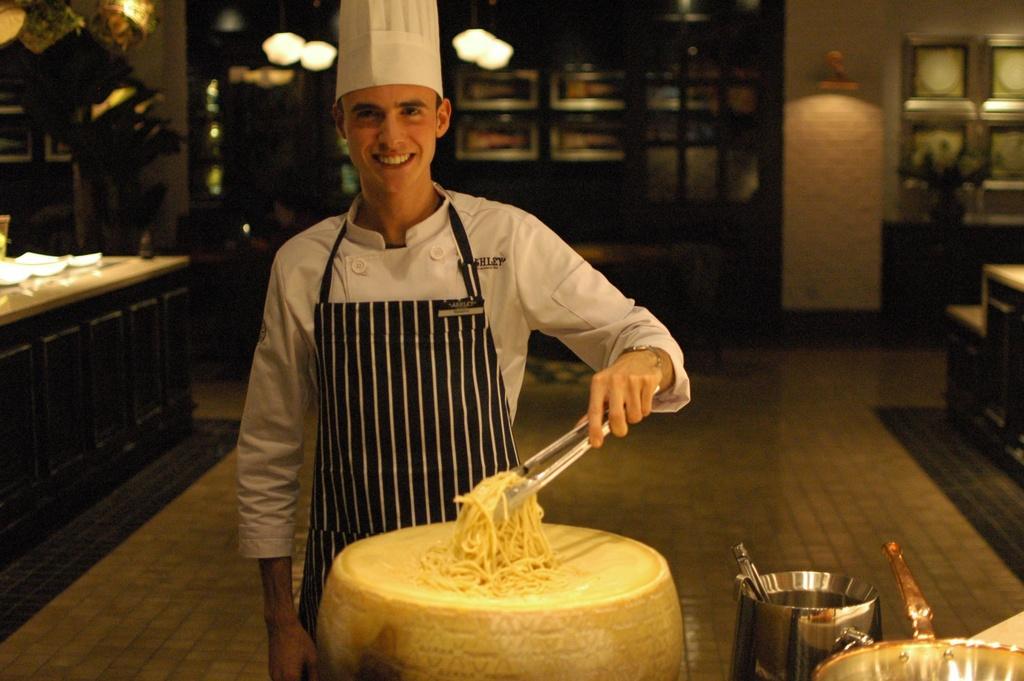Please provide a concise description of this image. In this picture we can see a man is standing and holding noodles using a tong, on the left side there is a table, we can see a bowl at the right bottom, in the background there are lights, they are looking like photo frames in the background. 